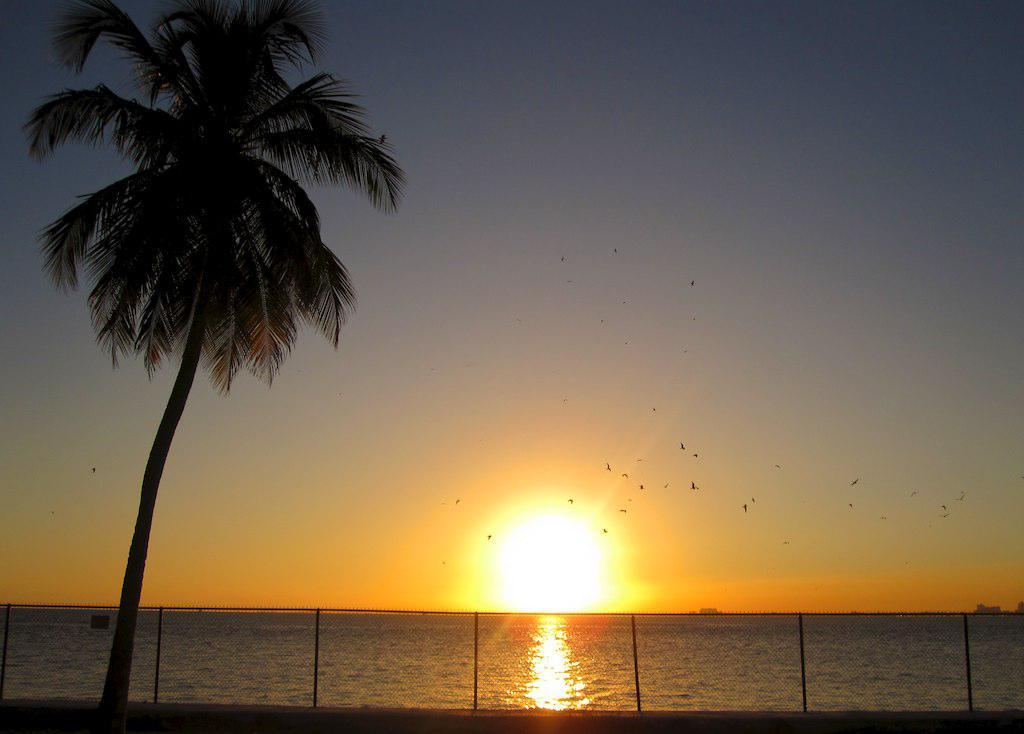What type of structure can be seen in the image? There is a mesh in the image. What natural element is present in the image? There is a tree in the image. What can be seen in the foreground of the image? Water is visible in the image. What is happening in the background of the image? The background of the image shows a sunset. What animals can be seen in the sky in the image? There are birds flying in the sky. What type of soup is being served in the image? There is no soup present in the image. What type of cord is attached to the tree in the image? There is no cord attached to the tree in the image. 